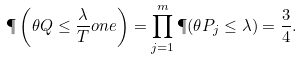<formula> <loc_0><loc_0><loc_500><loc_500>\P \left ( \theta Q \leq \frac { \lambda } { T } o n e \right ) = \prod _ { j = 1 } ^ { m } \P ( \theta P _ { j } \leq \lambda ) = \frac { 3 } { 4 } .</formula> 